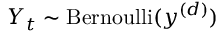<formula> <loc_0><loc_0><loc_500><loc_500>Y _ { t } \sim B e r n o u l l i ( y ^ { ( d ) } )</formula> 